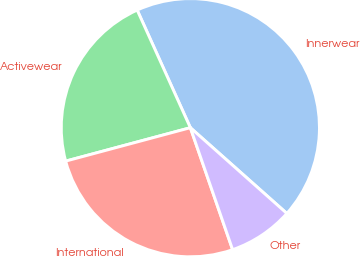Convert chart to OTSL. <chart><loc_0><loc_0><loc_500><loc_500><pie_chart><fcel>Innerwear<fcel>Activewear<fcel>International<fcel>Other<nl><fcel>43.32%<fcel>22.41%<fcel>26.14%<fcel>8.13%<nl></chart> 